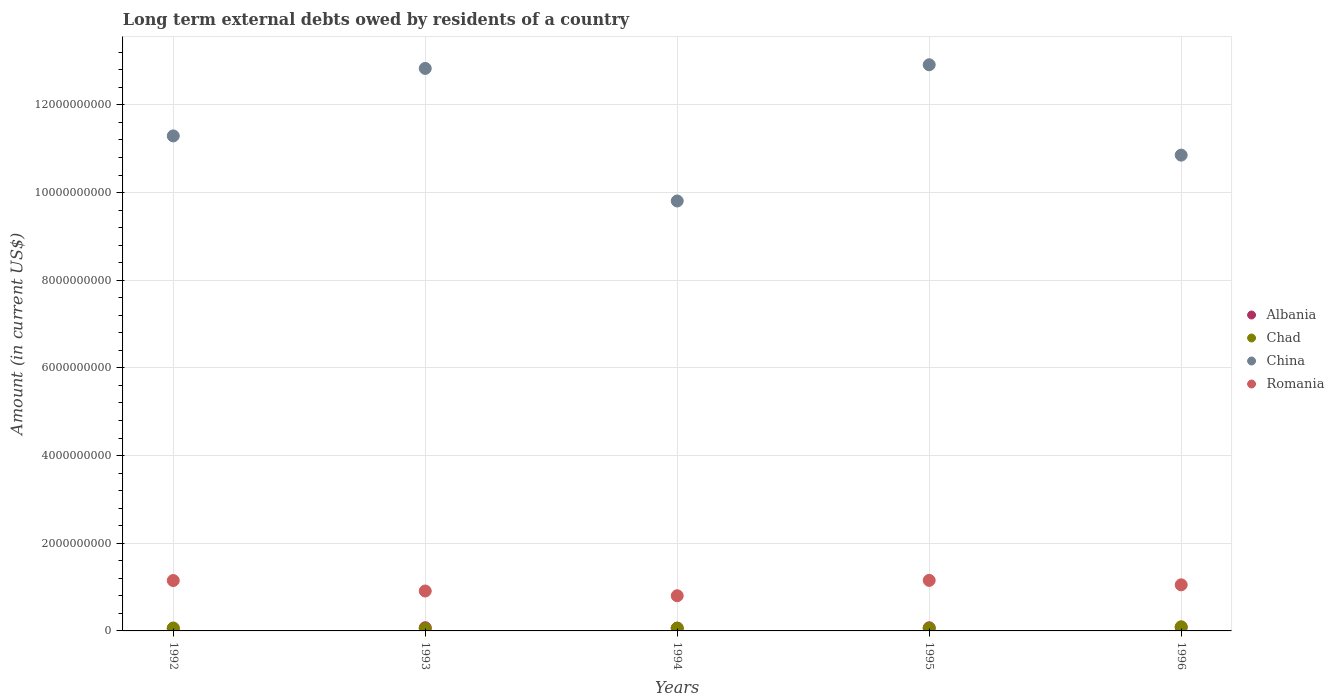Is the number of dotlines equal to the number of legend labels?
Your answer should be very brief. Yes. What is the amount of long-term external debts owed by residents in China in 1995?
Offer a terse response. 1.29e+1. Across all years, what is the maximum amount of long-term external debts owed by residents in Albania?
Give a very brief answer. 8.32e+07. Across all years, what is the minimum amount of long-term external debts owed by residents in Chad?
Ensure brevity in your answer.  5.25e+07. In which year was the amount of long-term external debts owed by residents in Chad maximum?
Provide a short and direct response. 1996. What is the total amount of long-term external debts owed by residents in China in the graph?
Your response must be concise. 5.77e+1. What is the difference between the amount of long-term external debts owed by residents in Romania in 1993 and that in 1996?
Your response must be concise. -1.41e+08. What is the difference between the amount of long-term external debts owed by residents in Chad in 1992 and the amount of long-term external debts owed by residents in Albania in 1996?
Your response must be concise. -1.63e+07. What is the average amount of long-term external debts owed by residents in Chad per year?
Provide a succinct answer. 6.68e+07. In the year 1992, what is the difference between the amount of long-term external debts owed by residents in China and amount of long-term external debts owed by residents in Chad?
Offer a terse response. 1.12e+1. In how many years, is the amount of long-term external debts owed by residents in Albania greater than 3200000000 US$?
Provide a succinct answer. 0. What is the ratio of the amount of long-term external debts owed by residents in China in 1992 to that in 1995?
Provide a succinct answer. 0.87. What is the difference between the highest and the second highest amount of long-term external debts owed by residents in China?
Your response must be concise. 8.31e+07. What is the difference between the highest and the lowest amount of long-term external debts owed by residents in China?
Your answer should be compact. 3.11e+09. In how many years, is the amount of long-term external debts owed by residents in China greater than the average amount of long-term external debts owed by residents in China taken over all years?
Your answer should be very brief. 2. Is it the case that in every year, the sum of the amount of long-term external debts owed by residents in Chad and amount of long-term external debts owed by residents in Albania  is greater than the sum of amount of long-term external debts owed by residents in China and amount of long-term external debts owed by residents in Romania?
Make the answer very short. Yes. Does the amount of long-term external debts owed by residents in China monotonically increase over the years?
Give a very brief answer. No. Is the amount of long-term external debts owed by residents in Albania strictly less than the amount of long-term external debts owed by residents in China over the years?
Provide a short and direct response. Yes. How many dotlines are there?
Provide a short and direct response. 4. What is the difference between two consecutive major ticks on the Y-axis?
Offer a terse response. 2.00e+09. Are the values on the major ticks of Y-axis written in scientific E-notation?
Offer a terse response. No. Does the graph contain grids?
Keep it short and to the point. Yes. Where does the legend appear in the graph?
Give a very brief answer. Center right. What is the title of the graph?
Your answer should be compact. Long term external debts owed by residents of a country. Does "Lebanon" appear as one of the legend labels in the graph?
Offer a terse response. No. What is the label or title of the X-axis?
Ensure brevity in your answer.  Years. What is the label or title of the Y-axis?
Your answer should be very brief. Amount (in current US$). What is the Amount (in current US$) in Albania in 1992?
Offer a terse response. 5.26e+07. What is the Amount (in current US$) in Chad in 1992?
Give a very brief answer. 6.69e+07. What is the Amount (in current US$) in China in 1992?
Your answer should be very brief. 1.13e+1. What is the Amount (in current US$) in Romania in 1992?
Provide a succinct answer. 1.15e+09. What is the Amount (in current US$) in Albania in 1993?
Give a very brief answer. 7.26e+07. What is the Amount (in current US$) of Chad in 1993?
Your answer should be very brief. 5.25e+07. What is the Amount (in current US$) of China in 1993?
Give a very brief answer. 1.28e+1. What is the Amount (in current US$) of Romania in 1993?
Give a very brief answer. 9.11e+08. What is the Amount (in current US$) in Albania in 1994?
Ensure brevity in your answer.  6.34e+07. What is the Amount (in current US$) in Chad in 1994?
Provide a succinct answer. 6.35e+07. What is the Amount (in current US$) of China in 1994?
Keep it short and to the point. 9.81e+09. What is the Amount (in current US$) in Romania in 1994?
Provide a succinct answer. 8.02e+08. What is the Amount (in current US$) in Albania in 1995?
Keep it short and to the point. 7.18e+07. What is the Amount (in current US$) in Chad in 1995?
Your answer should be compact. 5.74e+07. What is the Amount (in current US$) of China in 1995?
Ensure brevity in your answer.  1.29e+1. What is the Amount (in current US$) of Romania in 1995?
Ensure brevity in your answer.  1.15e+09. What is the Amount (in current US$) in Albania in 1996?
Ensure brevity in your answer.  8.32e+07. What is the Amount (in current US$) in Chad in 1996?
Offer a very short reply. 9.39e+07. What is the Amount (in current US$) of China in 1996?
Offer a terse response. 1.09e+1. What is the Amount (in current US$) of Romania in 1996?
Your answer should be compact. 1.05e+09. Across all years, what is the maximum Amount (in current US$) in Albania?
Offer a very short reply. 8.32e+07. Across all years, what is the maximum Amount (in current US$) of Chad?
Your answer should be very brief. 9.39e+07. Across all years, what is the maximum Amount (in current US$) in China?
Your response must be concise. 1.29e+1. Across all years, what is the maximum Amount (in current US$) in Romania?
Provide a succinct answer. 1.15e+09. Across all years, what is the minimum Amount (in current US$) in Albania?
Your response must be concise. 5.26e+07. Across all years, what is the minimum Amount (in current US$) of Chad?
Offer a very short reply. 5.25e+07. Across all years, what is the minimum Amount (in current US$) of China?
Your answer should be compact. 9.81e+09. Across all years, what is the minimum Amount (in current US$) in Romania?
Your answer should be very brief. 8.02e+08. What is the total Amount (in current US$) in Albania in the graph?
Keep it short and to the point. 3.44e+08. What is the total Amount (in current US$) in Chad in the graph?
Provide a short and direct response. 3.34e+08. What is the total Amount (in current US$) of China in the graph?
Provide a short and direct response. 5.77e+1. What is the total Amount (in current US$) in Romania in the graph?
Your response must be concise. 5.07e+09. What is the difference between the Amount (in current US$) of Albania in 1992 and that in 1993?
Ensure brevity in your answer.  -2.00e+07. What is the difference between the Amount (in current US$) in Chad in 1992 and that in 1993?
Keep it short and to the point. 1.44e+07. What is the difference between the Amount (in current US$) of China in 1992 and that in 1993?
Ensure brevity in your answer.  -1.54e+09. What is the difference between the Amount (in current US$) in Romania in 1992 and that in 1993?
Offer a very short reply. 2.39e+08. What is the difference between the Amount (in current US$) in Albania in 1992 and that in 1994?
Your answer should be compact. -1.09e+07. What is the difference between the Amount (in current US$) in Chad in 1992 and that in 1994?
Offer a terse response. 3.46e+06. What is the difference between the Amount (in current US$) of China in 1992 and that in 1994?
Offer a terse response. 1.48e+09. What is the difference between the Amount (in current US$) of Romania in 1992 and that in 1994?
Ensure brevity in your answer.  3.47e+08. What is the difference between the Amount (in current US$) of Albania in 1992 and that in 1995?
Offer a terse response. -1.92e+07. What is the difference between the Amount (in current US$) of Chad in 1992 and that in 1995?
Make the answer very short. 9.50e+06. What is the difference between the Amount (in current US$) of China in 1992 and that in 1995?
Provide a succinct answer. -1.62e+09. What is the difference between the Amount (in current US$) in Romania in 1992 and that in 1995?
Keep it short and to the point. -3.33e+06. What is the difference between the Amount (in current US$) in Albania in 1992 and that in 1996?
Offer a terse response. -3.06e+07. What is the difference between the Amount (in current US$) of Chad in 1992 and that in 1996?
Offer a very short reply. -2.70e+07. What is the difference between the Amount (in current US$) of China in 1992 and that in 1996?
Offer a terse response. 4.38e+08. What is the difference between the Amount (in current US$) of Romania in 1992 and that in 1996?
Keep it short and to the point. 9.79e+07. What is the difference between the Amount (in current US$) in Albania in 1993 and that in 1994?
Keep it short and to the point. 9.14e+06. What is the difference between the Amount (in current US$) of Chad in 1993 and that in 1994?
Provide a short and direct response. -1.10e+07. What is the difference between the Amount (in current US$) in China in 1993 and that in 1994?
Keep it short and to the point. 3.02e+09. What is the difference between the Amount (in current US$) of Romania in 1993 and that in 1994?
Ensure brevity in your answer.  1.08e+08. What is the difference between the Amount (in current US$) of Albania in 1993 and that in 1995?
Provide a short and direct response. 7.87e+05. What is the difference between the Amount (in current US$) in Chad in 1993 and that in 1995?
Ensure brevity in your answer.  -4.92e+06. What is the difference between the Amount (in current US$) in China in 1993 and that in 1995?
Provide a succinct answer. -8.31e+07. What is the difference between the Amount (in current US$) in Romania in 1993 and that in 1995?
Provide a short and direct response. -2.42e+08. What is the difference between the Amount (in current US$) in Albania in 1993 and that in 1996?
Give a very brief answer. -1.06e+07. What is the difference between the Amount (in current US$) of Chad in 1993 and that in 1996?
Ensure brevity in your answer.  -4.14e+07. What is the difference between the Amount (in current US$) of China in 1993 and that in 1996?
Your response must be concise. 1.98e+09. What is the difference between the Amount (in current US$) in Romania in 1993 and that in 1996?
Offer a very short reply. -1.41e+08. What is the difference between the Amount (in current US$) of Albania in 1994 and that in 1995?
Keep it short and to the point. -8.35e+06. What is the difference between the Amount (in current US$) of Chad in 1994 and that in 1995?
Your response must be concise. 6.05e+06. What is the difference between the Amount (in current US$) of China in 1994 and that in 1995?
Your response must be concise. -3.11e+09. What is the difference between the Amount (in current US$) of Romania in 1994 and that in 1995?
Offer a very short reply. -3.50e+08. What is the difference between the Amount (in current US$) in Albania in 1994 and that in 1996?
Keep it short and to the point. -1.98e+07. What is the difference between the Amount (in current US$) in Chad in 1994 and that in 1996?
Give a very brief answer. -3.04e+07. What is the difference between the Amount (in current US$) in China in 1994 and that in 1996?
Keep it short and to the point. -1.05e+09. What is the difference between the Amount (in current US$) in Romania in 1994 and that in 1996?
Provide a succinct answer. -2.49e+08. What is the difference between the Amount (in current US$) of Albania in 1995 and that in 1996?
Your answer should be compact. -1.14e+07. What is the difference between the Amount (in current US$) of Chad in 1995 and that in 1996?
Provide a short and direct response. -3.65e+07. What is the difference between the Amount (in current US$) in China in 1995 and that in 1996?
Make the answer very short. 2.06e+09. What is the difference between the Amount (in current US$) in Romania in 1995 and that in 1996?
Keep it short and to the point. 1.01e+08. What is the difference between the Amount (in current US$) of Albania in 1992 and the Amount (in current US$) of Chad in 1993?
Provide a succinct answer. 7.70e+04. What is the difference between the Amount (in current US$) in Albania in 1992 and the Amount (in current US$) in China in 1993?
Your response must be concise. -1.28e+1. What is the difference between the Amount (in current US$) in Albania in 1992 and the Amount (in current US$) in Romania in 1993?
Make the answer very short. -8.58e+08. What is the difference between the Amount (in current US$) in Chad in 1992 and the Amount (in current US$) in China in 1993?
Give a very brief answer. -1.28e+1. What is the difference between the Amount (in current US$) of Chad in 1992 and the Amount (in current US$) of Romania in 1993?
Your answer should be compact. -8.44e+08. What is the difference between the Amount (in current US$) of China in 1992 and the Amount (in current US$) of Romania in 1993?
Your response must be concise. 1.04e+1. What is the difference between the Amount (in current US$) of Albania in 1992 and the Amount (in current US$) of Chad in 1994?
Offer a very short reply. -1.09e+07. What is the difference between the Amount (in current US$) in Albania in 1992 and the Amount (in current US$) in China in 1994?
Your answer should be compact. -9.76e+09. What is the difference between the Amount (in current US$) in Albania in 1992 and the Amount (in current US$) in Romania in 1994?
Provide a succinct answer. -7.50e+08. What is the difference between the Amount (in current US$) of Chad in 1992 and the Amount (in current US$) of China in 1994?
Your response must be concise. -9.74e+09. What is the difference between the Amount (in current US$) in Chad in 1992 and the Amount (in current US$) in Romania in 1994?
Your response must be concise. -7.36e+08. What is the difference between the Amount (in current US$) in China in 1992 and the Amount (in current US$) in Romania in 1994?
Make the answer very short. 1.05e+1. What is the difference between the Amount (in current US$) of Albania in 1992 and the Amount (in current US$) of Chad in 1995?
Offer a very short reply. -4.84e+06. What is the difference between the Amount (in current US$) in Albania in 1992 and the Amount (in current US$) in China in 1995?
Your response must be concise. -1.29e+1. What is the difference between the Amount (in current US$) in Albania in 1992 and the Amount (in current US$) in Romania in 1995?
Keep it short and to the point. -1.10e+09. What is the difference between the Amount (in current US$) of Chad in 1992 and the Amount (in current US$) of China in 1995?
Ensure brevity in your answer.  -1.28e+1. What is the difference between the Amount (in current US$) of Chad in 1992 and the Amount (in current US$) of Romania in 1995?
Your answer should be very brief. -1.09e+09. What is the difference between the Amount (in current US$) in China in 1992 and the Amount (in current US$) in Romania in 1995?
Keep it short and to the point. 1.01e+1. What is the difference between the Amount (in current US$) in Albania in 1992 and the Amount (in current US$) in Chad in 1996?
Your answer should be very brief. -4.13e+07. What is the difference between the Amount (in current US$) in Albania in 1992 and the Amount (in current US$) in China in 1996?
Provide a succinct answer. -1.08e+1. What is the difference between the Amount (in current US$) in Albania in 1992 and the Amount (in current US$) in Romania in 1996?
Your answer should be compact. -9.99e+08. What is the difference between the Amount (in current US$) in Chad in 1992 and the Amount (in current US$) in China in 1996?
Give a very brief answer. -1.08e+1. What is the difference between the Amount (in current US$) of Chad in 1992 and the Amount (in current US$) of Romania in 1996?
Your answer should be very brief. -9.85e+08. What is the difference between the Amount (in current US$) in China in 1992 and the Amount (in current US$) in Romania in 1996?
Provide a short and direct response. 1.02e+1. What is the difference between the Amount (in current US$) in Albania in 1993 and the Amount (in current US$) in Chad in 1994?
Your answer should be very brief. 9.10e+06. What is the difference between the Amount (in current US$) of Albania in 1993 and the Amount (in current US$) of China in 1994?
Provide a succinct answer. -9.74e+09. What is the difference between the Amount (in current US$) in Albania in 1993 and the Amount (in current US$) in Romania in 1994?
Make the answer very short. -7.30e+08. What is the difference between the Amount (in current US$) in Chad in 1993 and the Amount (in current US$) in China in 1994?
Offer a very short reply. -9.76e+09. What is the difference between the Amount (in current US$) in Chad in 1993 and the Amount (in current US$) in Romania in 1994?
Provide a succinct answer. -7.50e+08. What is the difference between the Amount (in current US$) in China in 1993 and the Amount (in current US$) in Romania in 1994?
Your answer should be very brief. 1.20e+1. What is the difference between the Amount (in current US$) of Albania in 1993 and the Amount (in current US$) of Chad in 1995?
Your response must be concise. 1.52e+07. What is the difference between the Amount (in current US$) in Albania in 1993 and the Amount (in current US$) in China in 1995?
Your answer should be compact. -1.28e+1. What is the difference between the Amount (in current US$) of Albania in 1993 and the Amount (in current US$) of Romania in 1995?
Give a very brief answer. -1.08e+09. What is the difference between the Amount (in current US$) in Chad in 1993 and the Amount (in current US$) in China in 1995?
Offer a very short reply. -1.29e+1. What is the difference between the Amount (in current US$) of Chad in 1993 and the Amount (in current US$) of Romania in 1995?
Offer a terse response. -1.10e+09. What is the difference between the Amount (in current US$) of China in 1993 and the Amount (in current US$) of Romania in 1995?
Your answer should be compact. 1.17e+1. What is the difference between the Amount (in current US$) in Albania in 1993 and the Amount (in current US$) in Chad in 1996?
Make the answer very short. -2.13e+07. What is the difference between the Amount (in current US$) in Albania in 1993 and the Amount (in current US$) in China in 1996?
Make the answer very short. -1.08e+1. What is the difference between the Amount (in current US$) in Albania in 1993 and the Amount (in current US$) in Romania in 1996?
Offer a terse response. -9.79e+08. What is the difference between the Amount (in current US$) of Chad in 1993 and the Amount (in current US$) of China in 1996?
Give a very brief answer. -1.08e+1. What is the difference between the Amount (in current US$) of Chad in 1993 and the Amount (in current US$) of Romania in 1996?
Ensure brevity in your answer.  -9.99e+08. What is the difference between the Amount (in current US$) of China in 1993 and the Amount (in current US$) of Romania in 1996?
Offer a very short reply. 1.18e+1. What is the difference between the Amount (in current US$) in Albania in 1994 and the Amount (in current US$) in Chad in 1995?
Your response must be concise. 6.01e+06. What is the difference between the Amount (in current US$) of Albania in 1994 and the Amount (in current US$) of China in 1995?
Offer a terse response. -1.29e+1. What is the difference between the Amount (in current US$) of Albania in 1994 and the Amount (in current US$) of Romania in 1995?
Make the answer very short. -1.09e+09. What is the difference between the Amount (in current US$) in Chad in 1994 and the Amount (in current US$) in China in 1995?
Make the answer very short. -1.29e+1. What is the difference between the Amount (in current US$) in Chad in 1994 and the Amount (in current US$) in Romania in 1995?
Make the answer very short. -1.09e+09. What is the difference between the Amount (in current US$) in China in 1994 and the Amount (in current US$) in Romania in 1995?
Make the answer very short. 8.65e+09. What is the difference between the Amount (in current US$) of Albania in 1994 and the Amount (in current US$) of Chad in 1996?
Give a very brief answer. -3.05e+07. What is the difference between the Amount (in current US$) of Albania in 1994 and the Amount (in current US$) of China in 1996?
Provide a short and direct response. -1.08e+1. What is the difference between the Amount (in current US$) in Albania in 1994 and the Amount (in current US$) in Romania in 1996?
Make the answer very short. -9.88e+08. What is the difference between the Amount (in current US$) of Chad in 1994 and the Amount (in current US$) of China in 1996?
Provide a short and direct response. -1.08e+1. What is the difference between the Amount (in current US$) of Chad in 1994 and the Amount (in current US$) of Romania in 1996?
Your answer should be very brief. -9.88e+08. What is the difference between the Amount (in current US$) of China in 1994 and the Amount (in current US$) of Romania in 1996?
Provide a succinct answer. 8.76e+09. What is the difference between the Amount (in current US$) of Albania in 1995 and the Amount (in current US$) of Chad in 1996?
Ensure brevity in your answer.  -2.21e+07. What is the difference between the Amount (in current US$) of Albania in 1995 and the Amount (in current US$) of China in 1996?
Provide a short and direct response. -1.08e+1. What is the difference between the Amount (in current US$) of Albania in 1995 and the Amount (in current US$) of Romania in 1996?
Make the answer very short. -9.80e+08. What is the difference between the Amount (in current US$) of Chad in 1995 and the Amount (in current US$) of China in 1996?
Offer a very short reply. -1.08e+1. What is the difference between the Amount (in current US$) in Chad in 1995 and the Amount (in current US$) in Romania in 1996?
Offer a terse response. -9.94e+08. What is the difference between the Amount (in current US$) of China in 1995 and the Amount (in current US$) of Romania in 1996?
Offer a terse response. 1.19e+1. What is the average Amount (in current US$) of Albania per year?
Your answer should be compact. 6.87e+07. What is the average Amount (in current US$) in Chad per year?
Ensure brevity in your answer.  6.68e+07. What is the average Amount (in current US$) of China per year?
Provide a short and direct response. 1.15e+1. What is the average Amount (in current US$) of Romania per year?
Your answer should be very brief. 1.01e+09. In the year 1992, what is the difference between the Amount (in current US$) of Albania and Amount (in current US$) of Chad?
Offer a terse response. -1.43e+07. In the year 1992, what is the difference between the Amount (in current US$) of Albania and Amount (in current US$) of China?
Your answer should be compact. -1.12e+1. In the year 1992, what is the difference between the Amount (in current US$) in Albania and Amount (in current US$) in Romania?
Your answer should be compact. -1.10e+09. In the year 1992, what is the difference between the Amount (in current US$) of Chad and Amount (in current US$) of China?
Provide a succinct answer. -1.12e+1. In the year 1992, what is the difference between the Amount (in current US$) of Chad and Amount (in current US$) of Romania?
Provide a succinct answer. -1.08e+09. In the year 1992, what is the difference between the Amount (in current US$) of China and Amount (in current US$) of Romania?
Your answer should be very brief. 1.01e+1. In the year 1993, what is the difference between the Amount (in current US$) in Albania and Amount (in current US$) in Chad?
Your answer should be very brief. 2.01e+07. In the year 1993, what is the difference between the Amount (in current US$) in Albania and Amount (in current US$) in China?
Provide a short and direct response. -1.28e+1. In the year 1993, what is the difference between the Amount (in current US$) in Albania and Amount (in current US$) in Romania?
Your answer should be compact. -8.38e+08. In the year 1993, what is the difference between the Amount (in current US$) in Chad and Amount (in current US$) in China?
Offer a terse response. -1.28e+1. In the year 1993, what is the difference between the Amount (in current US$) of Chad and Amount (in current US$) of Romania?
Ensure brevity in your answer.  -8.58e+08. In the year 1993, what is the difference between the Amount (in current US$) of China and Amount (in current US$) of Romania?
Offer a very short reply. 1.19e+1. In the year 1994, what is the difference between the Amount (in current US$) of Albania and Amount (in current US$) of Chad?
Your response must be concise. -3.40e+04. In the year 1994, what is the difference between the Amount (in current US$) of Albania and Amount (in current US$) of China?
Give a very brief answer. -9.74e+09. In the year 1994, what is the difference between the Amount (in current US$) in Albania and Amount (in current US$) in Romania?
Your response must be concise. -7.39e+08. In the year 1994, what is the difference between the Amount (in current US$) in Chad and Amount (in current US$) in China?
Keep it short and to the point. -9.74e+09. In the year 1994, what is the difference between the Amount (in current US$) of Chad and Amount (in current US$) of Romania?
Give a very brief answer. -7.39e+08. In the year 1994, what is the difference between the Amount (in current US$) in China and Amount (in current US$) in Romania?
Provide a succinct answer. 9.01e+09. In the year 1995, what is the difference between the Amount (in current US$) in Albania and Amount (in current US$) in Chad?
Keep it short and to the point. 1.44e+07. In the year 1995, what is the difference between the Amount (in current US$) of Albania and Amount (in current US$) of China?
Your response must be concise. -1.28e+1. In the year 1995, what is the difference between the Amount (in current US$) of Albania and Amount (in current US$) of Romania?
Make the answer very short. -1.08e+09. In the year 1995, what is the difference between the Amount (in current US$) of Chad and Amount (in current US$) of China?
Ensure brevity in your answer.  -1.29e+1. In the year 1995, what is the difference between the Amount (in current US$) in Chad and Amount (in current US$) in Romania?
Provide a succinct answer. -1.10e+09. In the year 1995, what is the difference between the Amount (in current US$) in China and Amount (in current US$) in Romania?
Give a very brief answer. 1.18e+1. In the year 1996, what is the difference between the Amount (in current US$) of Albania and Amount (in current US$) of Chad?
Make the answer very short. -1.07e+07. In the year 1996, what is the difference between the Amount (in current US$) of Albania and Amount (in current US$) of China?
Provide a succinct answer. -1.08e+1. In the year 1996, what is the difference between the Amount (in current US$) in Albania and Amount (in current US$) in Romania?
Make the answer very short. -9.68e+08. In the year 1996, what is the difference between the Amount (in current US$) in Chad and Amount (in current US$) in China?
Keep it short and to the point. -1.08e+1. In the year 1996, what is the difference between the Amount (in current US$) in Chad and Amount (in current US$) in Romania?
Keep it short and to the point. -9.58e+08. In the year 1996, what is the difference between the Amount (in current US$) in China and Amount (in current US$) in Romania?
Ensure brevity in your answer.  9.80e+09. What is the ratio of the Amount (in current US$) in Albania in 1992 to that in 1993?
Keep it short and to the point. 0.72. What is the ratio of the Amount (in current US$) of Chad in 1992 to that in 1993?
Your answer should be very brief. 1.27. What is the ratio of the Amount (in current US$) in China in 1992 to that in 1993?
Make the answer very short. 0.88. What is the ratio of the Amount (in current US$) in Romania in 1992 to that in 1993?
Give a very brief answer. 1.26. What is the ratio of the Amount (in current US$) in Albania in 1992 to that in 1994?
Offer a very short reply. 0.83. What is the ratio of the Amount (in current US$) of Chad in 1992 to that in 1994?
Your answer should be very brief. 1.05. What is the ratio of the Amount (in current US$) in China in 1992 to that in 1994?
Your answer should be very brief. 1.15. What is the ratio of the Amount (in current US$) of Romania in 1992 to that in 1994?
Your response must be concise. 1.43. What is the ratio of the Amount (in current US$) in Albania in 1992 to that in 1995?
Ensure brevity in your answer.  0.73. What is the ratio of the Amount (in current US$) of Chad in 1992 to that in 1995?
Offer a very short reply. 1.17. What is the ratio of the Amount (in current US$) in China in 1992 to that in 1995?
Your answer should be compact. 0.87. What is the ratio of the Amount (in current US$) of Albania in 1992 to that in 1996?
Ensure brevity in your answer.  0.63. What is the ratio of the Amount (in current US$) of Chad in 1992 to that in 1996?
Give a very brief answer. 0.71. What is the ratio of the Amount (in current US$) in China in 1992 to that in 1996?
Make the answer very short. 1.04. What is the ratio of the Amount (in current US$) in Romania in 1992 to that in 1996?
Your answer should be compact. 1.09. What is the ratio of the Amount (in current US$) in Albania in 1993 to that in 1994?
Provide a succinct answer. 1.14. What is the ratio of the Amount (in current US$) in Chad in 1993 to that in 1994?
Provide a succinct answer. 0.83. What is the ratio of the Amount (in current US$) in China in 1993 to that in 1994?
Offer a terse response. 1.31. What is the ratio of the Amount (in current US$) in Romania in 1993 to that in 1994?
Provide a short and direct response. 1.13. What is the ratio of the Amount (in current US$) in Chad in 1993 to that in 1995?
Give a very brief answer. 0.91. What is the ratio of the Amount (in current US$) in China in 1993 to that in 1995?
Offer a terse response. 0.99. What is the ratio of the Amount (in current US$) in Romania in 1993 to that in 1995?
Provide a succinct answer. 0.79. What is the ratio of the Amount (in current US$) in Albania in 1993 to that in 1996?
Your answer should be compact. 0.87. What is the ratio of the Amount (in current US$) in Chad in 1993 to that in 1996?
Provide a short and direct response. 0.56. What is the ratio of the Amount (in current US$) in China in 1993 to that in 1996?
Provide a short and direct response. 1.18. What is the ratio of the Amount (in current US$) of Romania in 1993 to that in 1996?
Your response must be concise. 0.87. What is the ratio of the Amount (in current US$) in Albania in 1994 to that in 1995?
Provide a succinct answer. 0.88. What is the ratio of the Amount (in current US$) in Chad in 1994 to that in 1995?
Ensure brevity in your answer.  1.11. What is the ratio of the Amount (in current US$) in China in 1994 to that in 1995?
Your answer should be very brief. 0.76. What is the ratio of the Amount (in current US$) in Romania in 1994 to that in 1995?
Provide a short and direct response. 0.7. What is the ratio of the Amount (in current US$) of Albania in 1994 to that in 1996?
Offer a very short reply. 0.76. What is the ratio of the Amount (in current US$) of Chad in 1994 to that in 1996?
Your response must be concise. 0.68. What is the ratio of the Amount (in current US$) in China in 1994 to that in 1996?
Keep it short and to the point. 0.9. What is the ratio of the Amount (in current US$) in Romania in 1994 to that in 1996?
Ensure brevity in your answer.  0.76. What is the ratio of the Amount (in current US$) of Albania in 1995 to that in 1996?
Offer a very short reply. 0.86. What is the ratio of the Amount (in current US$) in Chad in 1995 to that in 1996?
Give a very brief answer. 0.61. What is the ratio of the Amount (in current US$) of China in 1995 to that in 1996?
Offer a very short reply. 1.19. What is the ratio of the Amount (in current US$) of Romania in 1995 to that in 1996?
Offer a terse response. 1.1. What is the difference between the highest and the second highest Amount (in current US$) in Albania?
Offer a terse response. 1.06e+07. What is the difference between the highest and the second highest Amount (in current US$) in Chad?
Keep it short and to the point. 2.70e+07. What is the difference between the highest and the second highest Amount (in current US$) of China?
Give a very brief answer. 8.31e+07. What is the difference between the highest and the second highest Amount (in current US$) in Romania?
Your answer should be compact. 3.33e+06. What is the difference between the highest and the lowest Amount (in current US$) in Albania?
Make the answer very short. 3.06e+07. What is the difference between the highest and the lowest Amount (in current US$) in Chad?
Ensure brevity in your answer.  4.14e+07. What is the difference between the highest and the lowest Amount (in current US$) in China?
Make the answer very short. 3.11e+09. What is the difference between the highest and the lowest Amount (in current US$) of Romania?
Provide a short and direct response. 3.50e+08. 